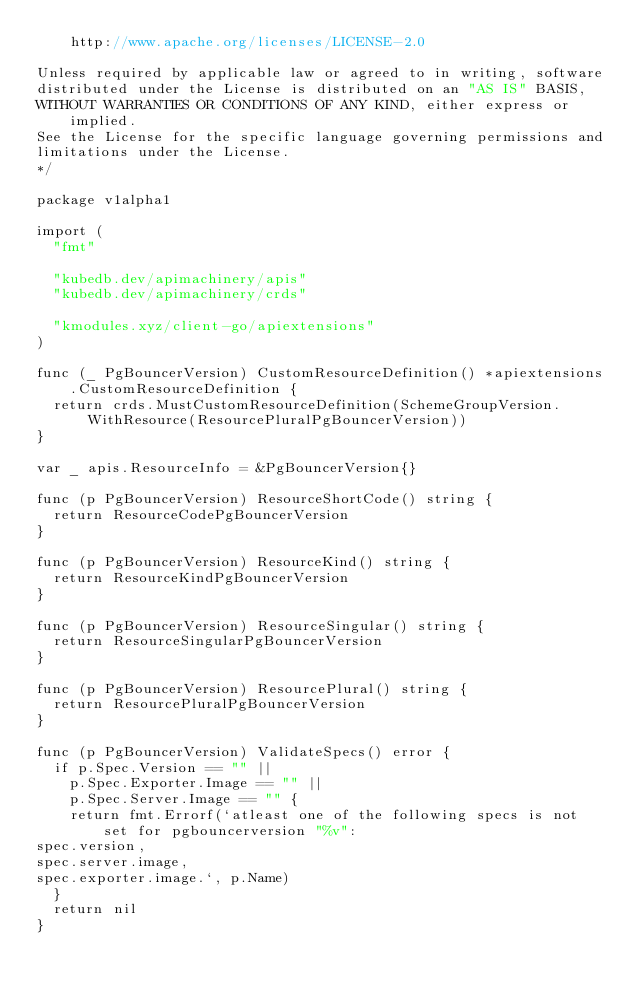Convert code to text. <code><loc_0><loc_0><loc_500><loc_500><_Go_>    http://www.apache.org/licenses/LICENSE-2.0

Unless required by applicable law or agreed to in writing, software
distributed under the License is distributed on an "AS IS" BASIS,
WITHOUT WARRANTIES OR CONDITIONS OF ANY KIND, either express or implied.
See the License for the specific language governing permissions and
limitations under the License.
*/

package v1alpha1

import (
	"fmt"

	"kubedb.dev/apimachinery/apis"
	"kubedb.dev/apimachinery/crds"

	"kmodules.xyz/client-go/apiextensions"
)

func (_ PgBouncerVersion) CustomResourceDefinition() *apiextensions.CustomResourceDefinition {
	return crds.MustCustomResourceDefinition(SchemeGroupVersion.WithResource(ResourcePluralPgBouncerVersion))
}

var _ apis.ResourceInfo = &PgBouncerVersion{}

func (p PgBouncerVersion) ResourceShortCode() string {
	return ResourceCodePgBouncerVersion
}

func (p PgBouncerVersion) ResourceKind() string {
	return ResourceKindPgBouncerVersion
}

func (p PgBouncerVersion) ResourceSingular() string {
	return ResourceSingularPgBouncerVersion
}

func (p PgBouncerVersion) ResourcePlural() string {
	return ResourcePluralPgBouncerVersion
}

func (p PgBouncerVersion) ValidateSpecs() error {
	if p.Spec.Version == "" ||
		p.Spec.Exporter.Image == "" ||
		p.Spec.Server.Image == "" {
		return fmt.Errorf(`atleast one of the following specs is not set for pgbouncerversion "%v":
spec.version,
spec.server.image,
spec.exporter.image.`, p.Name)
	}
	return nil
}
</code> 